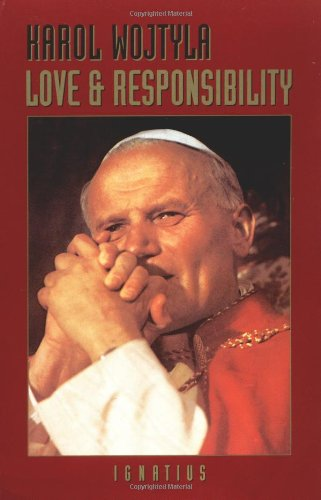Is this an art related book? No, this book is not related to art. It focuses on philosophical and theological reflections on human love and responsibilities, offering insights into ethical interpersonal relationships. 